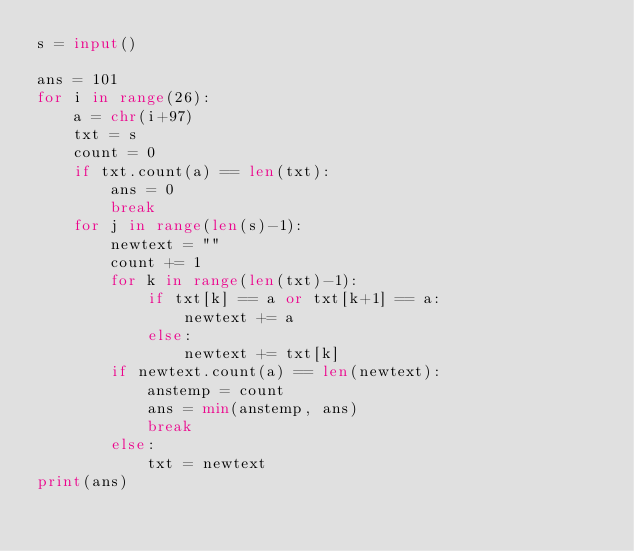<code> <loc_0><loc_0><loc_500><loc_500><_Python_>s = input()

ans = 101
for i in range(26):
    a = chr(i+97)
    txt = s
    count = 0
    if txt.count(a) == len(txt):
        ans = 0
        break
    for j in range(len(s)-1):
        newtext = ""
        count += 1
        for k in range(len(txt)-1):
            if txt[k] == a or txt[k+1] == a:
                newtext += a
            else:
                newtext += txt[k]
        if newtext.count(a) == len(newtext):
            anstemp = count
            ans = min(anstemp, ans)
            break
        else:
            txt = newtext
print(ans)
</code> 